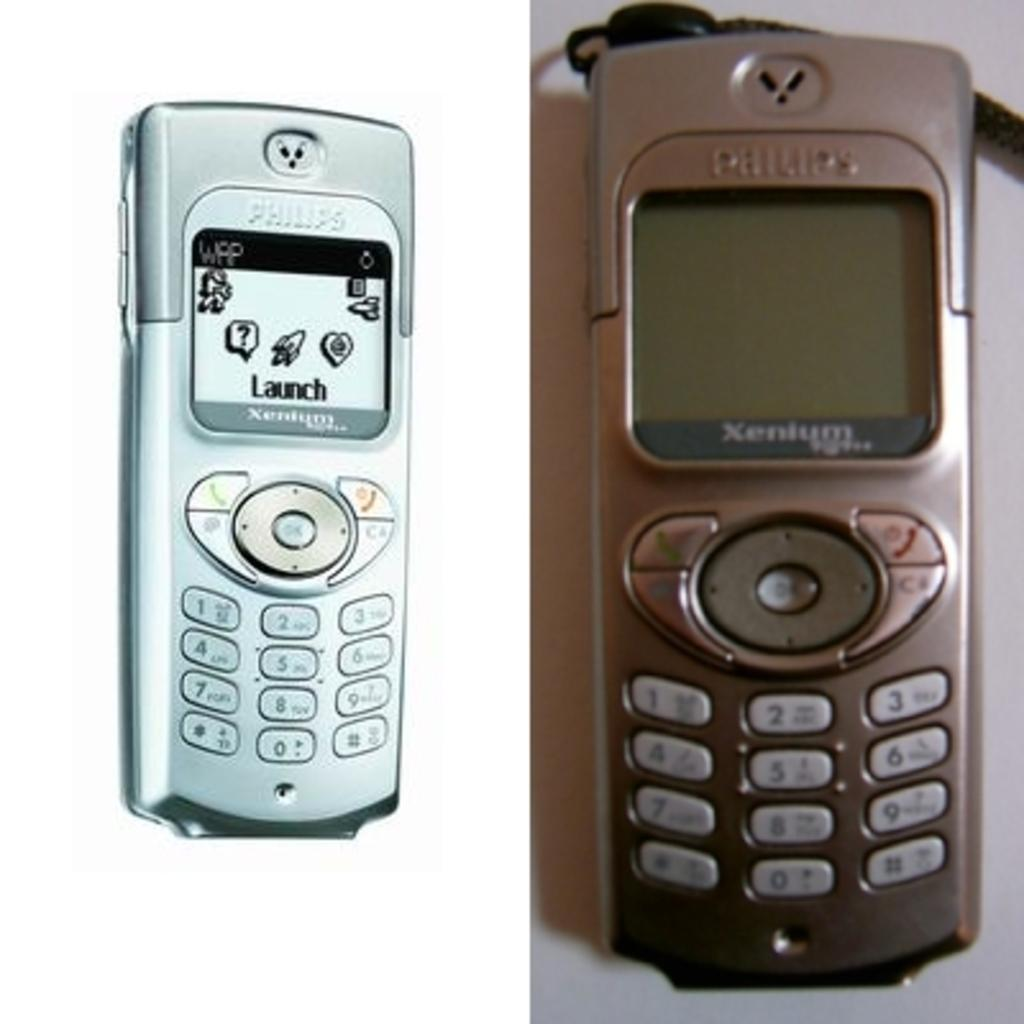<image>
Relay a brief, clear account of the picture shown. a Philips cell phone has a screen reading Launch 